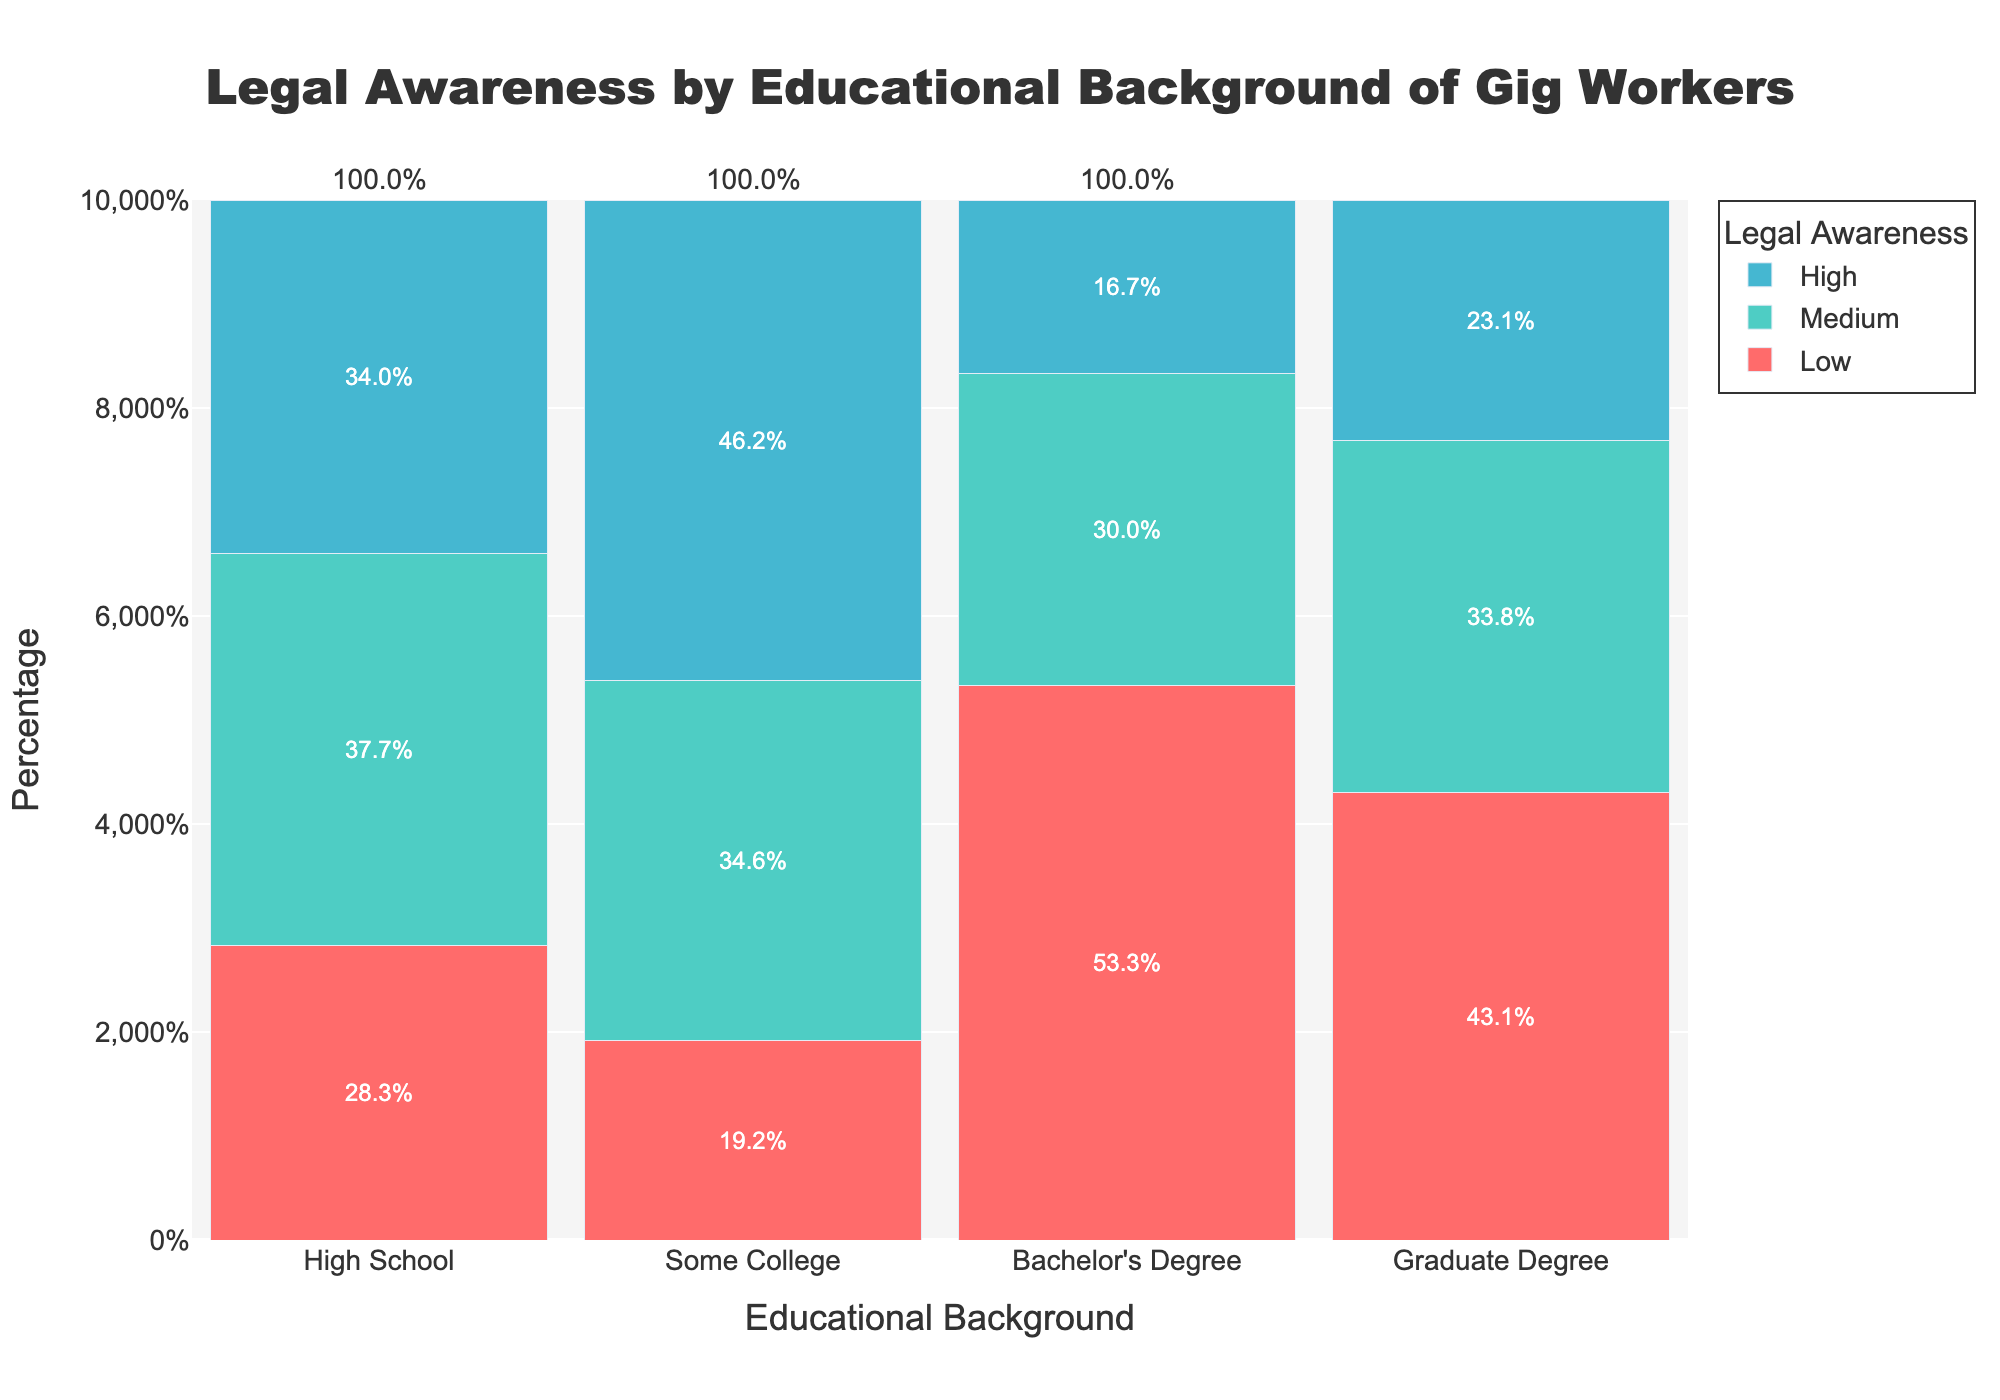What's the title of the figure? The title of a figure is generally placed at the top and clearly identifies the subject of the plot. By examining the figure, the title reads 'Legal Awareness by Educational Background of Gig Workers'.
Answer: Legal Awareness by Educational Background of Gig Workers What educational level has the highest percentage of workers with high legal awareness? To determine this, look at the category with the longest bar segment in the 'High' legal awareness section. The longest segment is for 'Graduate Degree'.
Answer: Graduate Degree Which educational category has workers with the lowest level of legal awareness? To find this, observe the 'Low' legal awareness bar segments. The largest segment indicates the category with the most workers with low awareness, which is 'High School'.
Answer: High School Compare the percentages of workers with medium legal awareness between those with Some College and Bachelor's Degree. Look at the 'Medium' bar segments for both 'Some College' and 'Bachelor's Degree' categories. The segment for Bachelor's Degree is slightly longer than Some College.
Answer: Bachelor's Degree has a higher percentage What is the percentage of gig workers with a Bachelor's Degree and high legal awareness? Locate the 'Bachelor's Degree' category and then find the yellow segment representing 'High' legal awareness. The text inside the bar shows the percentage.
Answer: 15.5% How does the percentage of workers with a High School degree and medium legal awareness compare to those with a Graduate Degree and medium legal awareness? Identify the 'Medium' legal awareness segments for both 'High School' and 'Graduate Degree'. Compare their lengths and the percentages displayed. 'High School' has a shorter segment with 18%, while 'Graduate Degree' is 36%.
Answer: Graduate Degree is higher What is the total percentage of workers with some form of college education (Some College and Bachelor's Degree) and high legal awareness? Sum the percentages of 'High' legal awareness for both 'Some College' (15%) and 'Bachelor's Degree' (20%). Addition gives 35%.
Answer: 35% Which category has the smallest range of legal awareness levels? Check for the category with the least difference between the highest and the lowest percentages across all legal awareness levels. 'Graduate Degree' has values 18, 10, and 12 which are closer together.
Answer: Graduate Degree How does legal awareness vary as the level of education increases? Observe the trend in bar heights from 'High School' to 'Graduate Degree' across 'Low', 'Medium', and 'High' segments. As education level increases, the proportion of 'High' awareness grows while 'Low' awareness decreases. Higher education levels generally correspond with higher legal awareness.
Answer: Increases with education What's the combined percentage of gig workers with a High School education having either low or medium legal awareness? Add the percentages of 'Low' (60%) and 'Medium' (18%) for 'High School'. Addition gives 78%.
Answer: 78% 